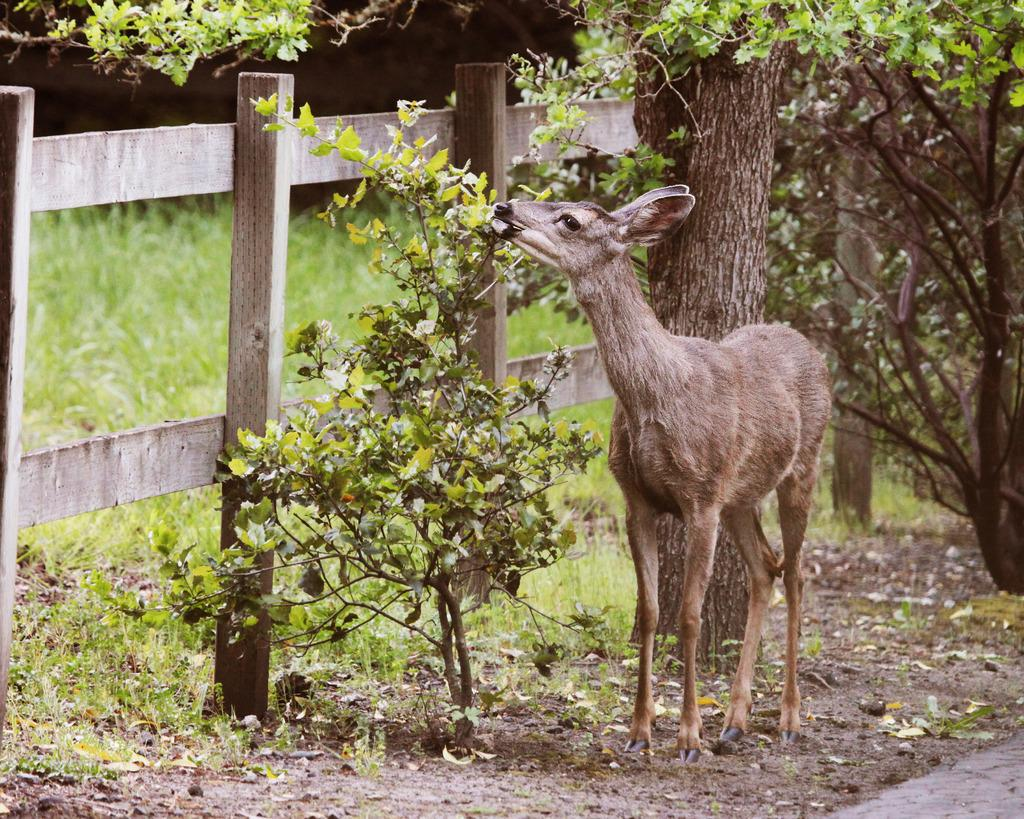What animal can be seen in the image? There is a deer in the image. What is visible at the bottom of the image? The ground is visible at the bottom of the image. What type of fencing is on the left side of the image? There is a wooden fencing on the left side of the image. What type of vegetation is present in the image? Plants are present in the image. What color is the grass visible on the ground? Green grass is visible on the ground. How many basketballs can be seen in the image? There are no basketballs present in the image. 